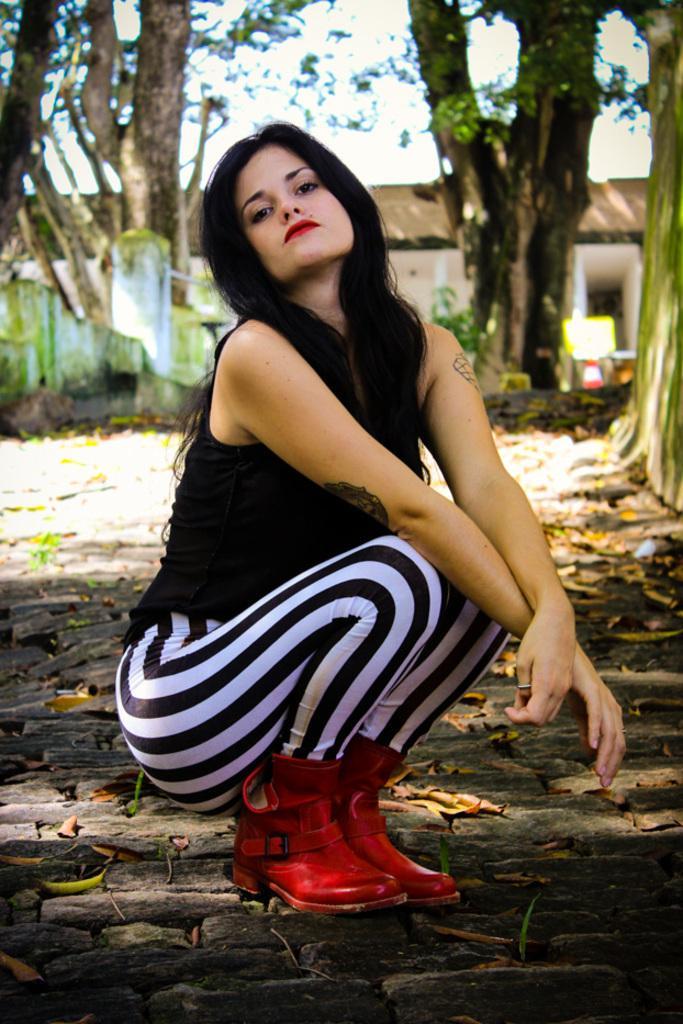Can you describe this image briefly? In the middle of this image, there is a woman in a black color t-shirt, squatting on the ground on which there are leaves. In the background, there are trees, a building and there are clouds in the sky. 